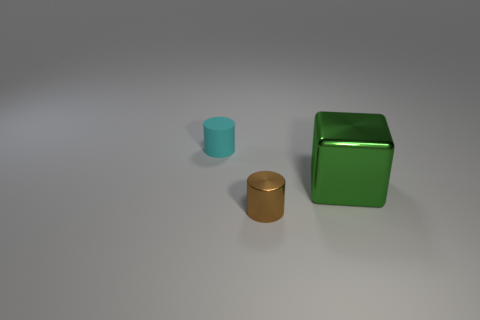Does the image seem to have any specific mood or atmosphere? The image conveys a minimalist and serene atmosphere. The soft lighting and the simple positioning of the objects on a neutral background contribute to a calm and orderly visual experience. Imagine if these objects were part of a still life painting, what additional elements could be included to complement them? To complement these objects in a still life painting, one might include items such as a draped cloth to add texture, a glass vase or some flowers for organic shapes, and perhaps a fruit or a book to introduce elements of everyday life. 